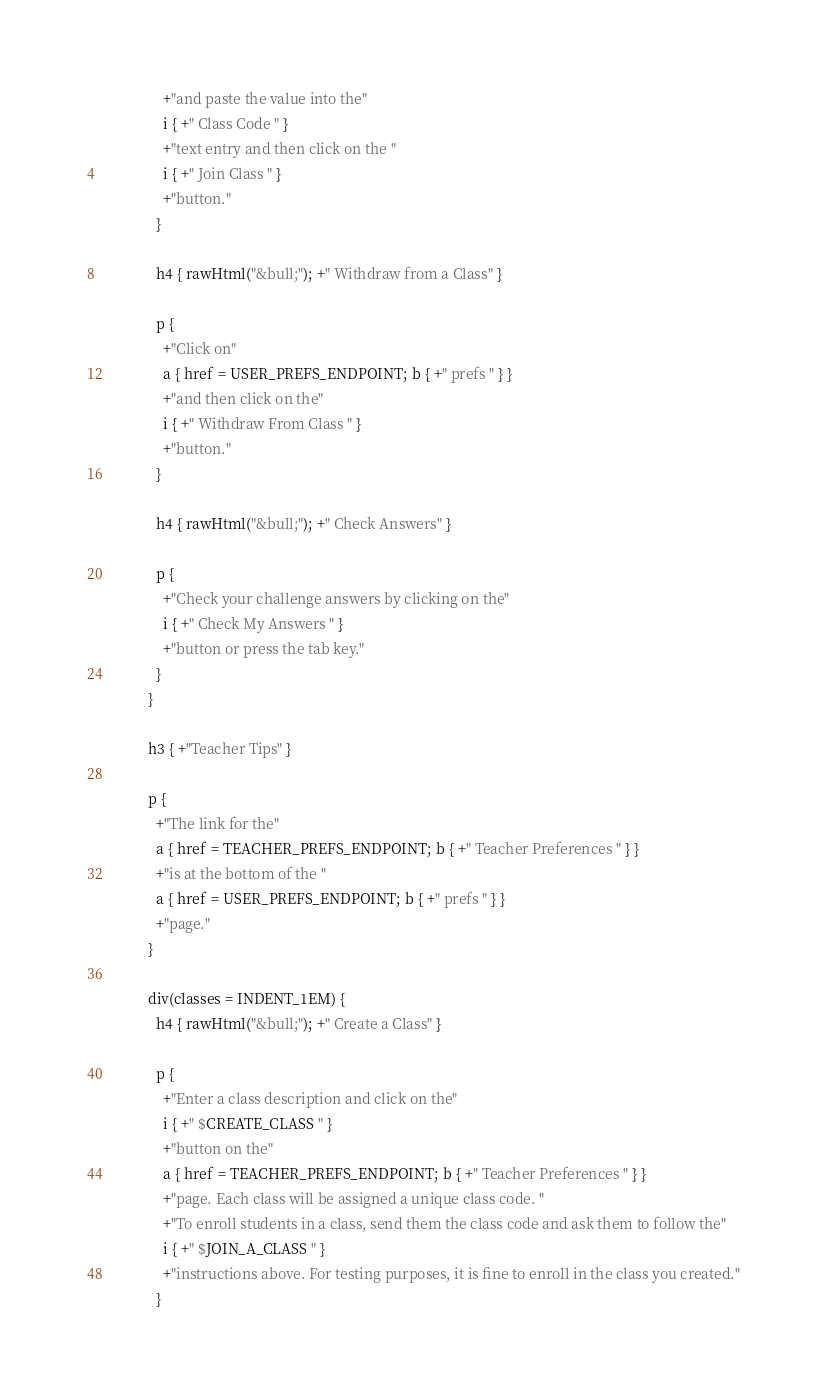Convert code to text. <code><loc_0><loc_0><loc_500><loc_500><_Kotlin_>                +"and paste the value into the"
                i { +" Class Code " }
                +"text entry and then click on the "
                i { +" Join Class " }
                +"button."
              }

              h4 { rawHtml("&bull;"); +" Withdraw from a Class" }

              p {
                +"Click on"
                a { href = USER_PREFS_ENDPOINT; b { +" prefs " } }
                +"and then click on the"
                i { +" Withdraw From Class " }
                +"button."
              }

              h4 { rawHtml("&bull;"); +" Check Answers" }

              p {
                +"Check your challenge answers by clicking on the"
                i { +" Check My Answers " }
                +"button or press the tab key."
              }
            }

            h3 { +"Teacher Tips" }

            p {
              +"The link for the"
              a { href = TEACHER_PREFS_ENDPOINT; b { +" Teacher Preferences " } }
              +"is at the bottom of the "
              a { href = USER_PREFS_ENDPOINT; b { +" prefs " } }
              +"page."
            }

            div(classes = INDENT_1EM) {
              h4 { rawHtml("&bull;"); +" Create a Class" }

              p {
                +"Enter a class description and click on the"
                i { +" $CREATE_CLASS " }
                +"button on the"
                a { href = TEACHER_PREFS_ENDPOINT; b { +" Teacher Preferences " } }
                +"page. Each class will be assigned a unique class code. "
                +"To enroll students in a class, send them the class code and ask them to follow the"
                i { +" $JOIN_A_CLASS " }
                +"instructions above. For testing purposes, it is fine to enroll in the class you created."
              }
</code> 